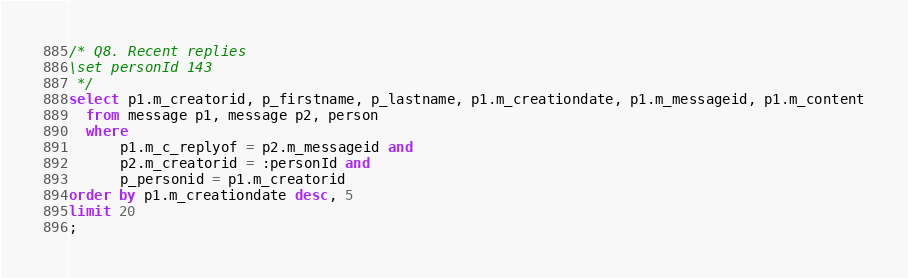Convert code to text. <code><loc_0><loc_0><loc_500><loc_500><_SQL_>/* Q8. Recent replies
\set personId 143
 */
select p1.m_creatorid, p_firstname, p_lastname, p1.m_creationdate, p1.m_messageid, p1.m_content
  from message p1, message p2, person
  where
      p1.m_c_replyof = p2.m_messageid and
      p2.m_creatorid = :personId and
      p_personid = p1.m_creatorid
order by p1.m_creationdate desc, 5
limit 20
;
</code> 